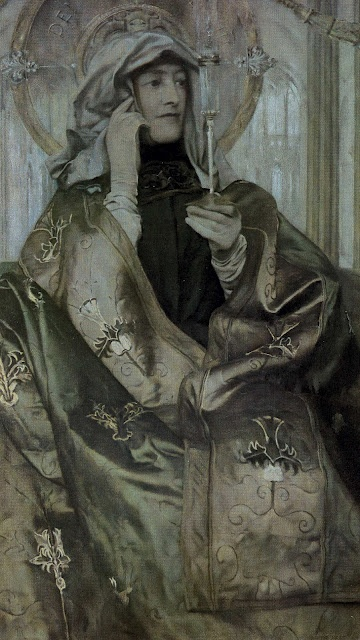Is there anything about this image that suggests a specific time of day? The image does not provide explicit clues about a specific time of day, as the background is relatively neutral and does not depict any direct light sources or shadows that might indicate morning, afternoon, or evening. However, the serene and calm atmosphere of the portrait could suggest a quiet time, possibly early morning or late afternoon, when the woman might find solitude for personal reflection. 